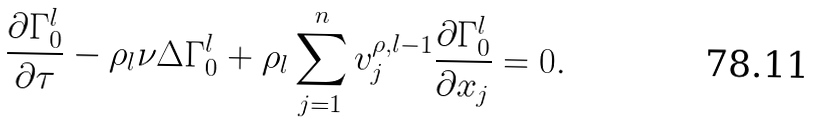<formula> <loc_0><loc_0><loc_500><loc_500>\frac { \partial \Gamma ^ { l } _ { 0 } } { \partial \tau } - \rho _ { l } \nu \Delta \Gamma ^ { l } _ { 0 } + \rho _ { l } \sum _ { j = 1 } ^ { n } v ^ { \rho , l - 1 } _ { j } \frac { \partial \Gamma ^ { l } _ { 0 } } { \partial x _ { j } } = 0 .</formula> 